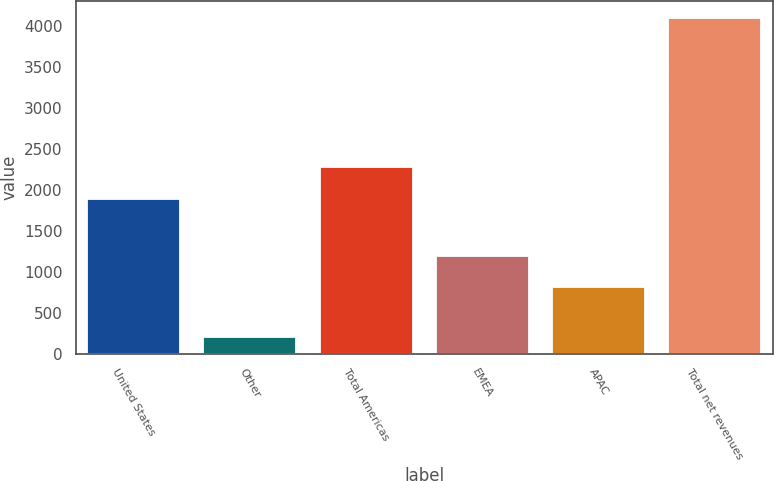<chart> <loc_0><loc_0><loc_500><loc_500><bar_chart><fcel>United States<fcel>Other<fcel>Total Americas<fcel>EMEA<fcel>APAC<fcel>Total net revenues<nl><fcel>1890.1<fcel>205.5<fcel>2278.88<fcel>1197.18<fcel>808.4<fcel>4093.3<nl></chart> 